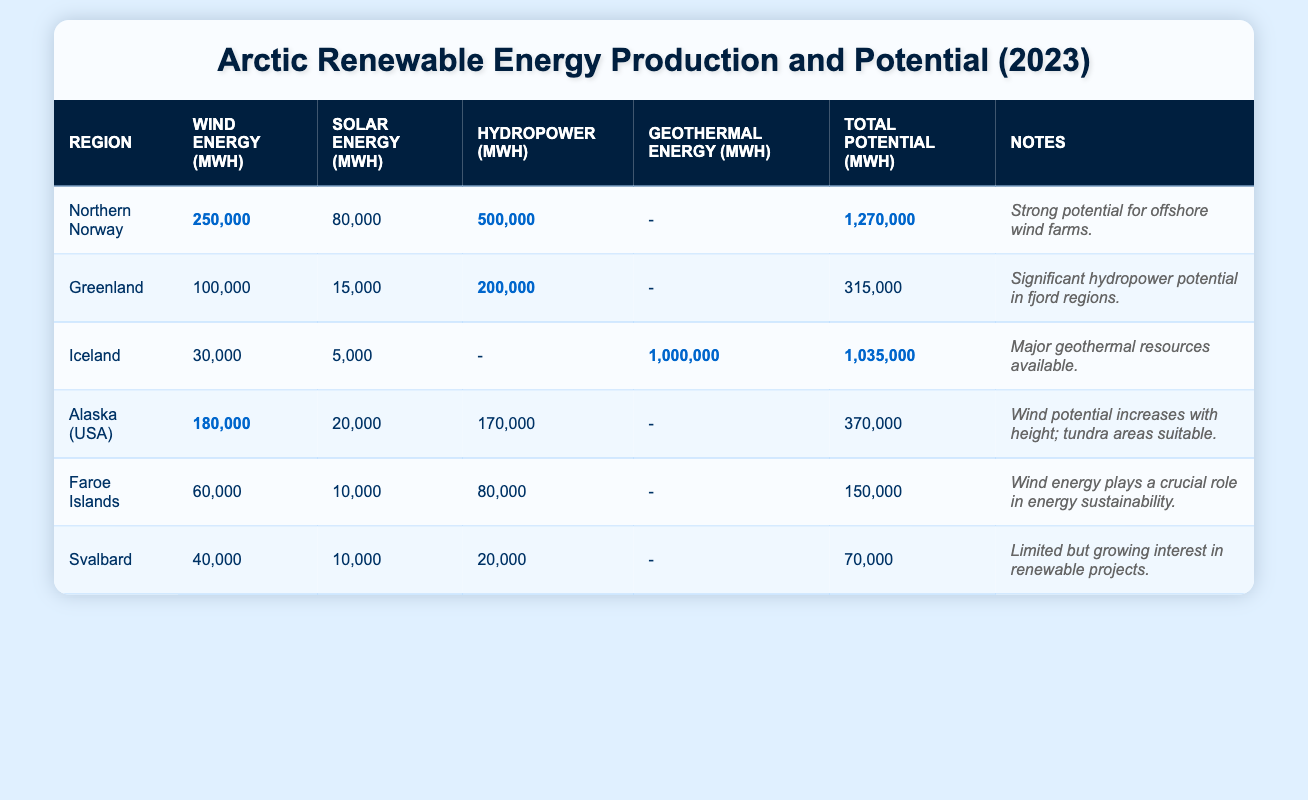What is the total renewable energy potential for Northern Norway? The table lists the total renewable energy potential for Northern Norway as 1,270,000 MWh.
Answer: 1,270,000 MWh Which region has the highest wind energy production? According to the table, Northern Norway has the highest wind energy production at 250,000 MWh.
Answer: Northern Norway What is the difference in total renewable energy potential between Greenland and Svalbard? Greenland has a total renewable energy potential of 315,000 MWh and Svalbard has 70,000 MWh. The difference is 315,000 - 70,000 = 245,000 MWh.
Answer: 245,000 MWh Is there any region that has geothermal energy production? Yes, Iceland has geothermal energy production listed at 1,000,000 MWh.
Answer: Yes What is the total wind energy production across all regions in the table? The total wind energy production is found by adding the values: 250,000 + 100,000 + 30,000 + 180,000 + 60,000 + 40,000 = 660,000 MWh.
Answer: 660,000 MWh Which region has the lowest total renewable energy potential? The table shows that Svalbard has the lowest total renewable energy potential at 70,000 MWh, compared to other regions.
Answer: Svalbard If we average the hydropower production of all regions, what would it be? Calculating the hydropower production values: 500,000 + 200,000 + 0 + 170,000 + 80,000 + 20,000 = 970,000 MWh. There are 6 regions with hydropower production, thus the average is 970,000 / 6 = approximately 161,667 MWh.
Answer: Approximately 161,667 MWh What percentage of total renewable energy potential does Iceland derive from geothermal energy? Iceland’s geothermal energy production is 1,000,000 MWh out of a total potential of 1,035,000 MWh. The percentage is (1,000,000 / 1,035,000) * 100 = approximately 96.6%.
Answer: Approximately 96.6% Combine the wind and solar energy production of the Faroe Islands. The Faroe Islands' wind energy production is 60,000 MWh and solar energy production is 10,000 MWh. Adding these gives 60,000 + 10,000 = 70,000 MWh.
Answer: 70,000 MWh What is the total renewable energy production from Alaska (USA) if we combine all forms of energy listed? Alaska's energy production includes wind (180,000 MWh), solar (20,000 MWh), and hydropower (170,000 MWh). Adding these values gives 180,000 + 20,000 + 170,000 = 370,000 MWh.
Answer: 370,000 MWh 